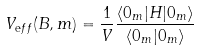Convert formula to latex. <formula><loc_0><loc_0><loc_500><loc_500>V _ { \mathrm e f f } ( B , m ) = \frac { 1 } { V } \frac { \langle 0 _ { m } | H | 0 _ { m } \rangle } { \langle 0 _ { m } | 0 _ { m } \rangle }</formula> 